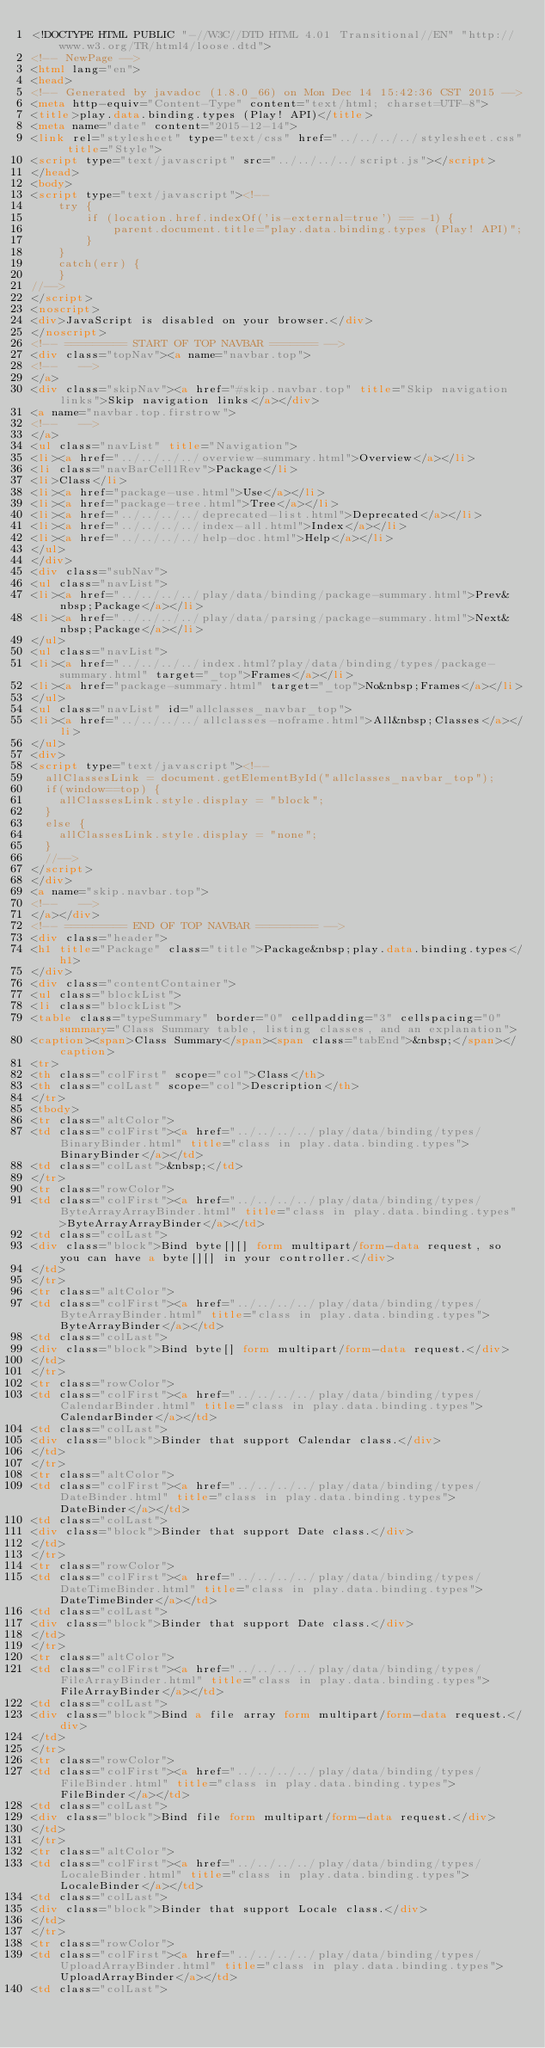Convert code to text. <code><loc_0><loc_0><loc_500><loc_500><_HTML_><!DOCTYPE HTML PUBLIC "-//W3C//DTD HTML 4.01 Transitional//EN" "http://www.w3.org/TR/html4/loose.dtd">
<!-- NewPage -->
<html lang="en">
<head>
<!-- Generated by javadoc (1.8.0_66) on Mon Dec 14 15:42:36 CST 2015 -->
<meta http-equiv="Content-Type" content="text/html; charset=UTF-8">
<title>play.data.binding.types (Play! API)</title>
<meta name="date" content="2015-12-14">
<link rel="stylesheet" type="text/css" href="../../../../stylesheet.css" title="Style">
<script type="text/javascript" src="../../../../script.js"></script>
</head>
<body>
<script type="text/javascript"><!--
    try {
        if (location.href.indexOf('is-external=true') == -1) {
            parent.document.title="play.data.binding.types (Play! API)";
        }
    }
    catch(err) {
    }
//-->
</script>
<noscript>
<div>JavaScript is disabled on your browser.</div>
</noscript>
<!-- ========= START OF TOP NAVBAR ======= -->
<div class="topNav"><a name="navbar.top">
<!--   -->
</a>
<div class="skipNav"><a href="#skip.navbar.top" title="Skip navigation links">Skip navigation links</a></div>
<a name="navbar.top.firstrow">
<!--   -->
</a>
<ul class="navList" title="Navigation">
<li><a href="../../../../overview-summary.html">Overview</a></li>
<li class="navBarCell1Rev">Package</li>
<li>Class</li>
<li><a href="package-use.html">Use</a></li>
<li><a href="package-tree.html">Tree</a></li>
<li><a href="../../../../deprecated-list.html">Deprecated</a></li>
<li><a href="../../../../index-all.html">Index</a></li>
<li><a href="../../../../help-doc.html">Help</a></li>
</ul>
</div>
<div class="subNav">
<ul class="navList">
<li><a href="../../../../play/data/binding/package-summary.html">Prev&nbsp;Package</a></li>
<li><a href="../../../../play/data/parsing/package-summary.html">Next&nbsp;Package</a></li>
</ul>
<ul class="navList">
<li><a href="../../../../index.html?play/data/binding/types/package-summary.html" target="_top">Frames</a></li>
<li><a href="package-summary.html" target="_top">No&nbsp;Frames</a></li>
</ul>
<ul class="navList" id="allclasses_navbar_top">
<li><a href="../../../../allclasses-noframe.html">All&nbsp;Classes</a></li>
</ul>
<div>
<script type="text/javascript"><!--
  allClassesLink = document.getElementById("allclasses_navbar_top");
  if(window==top) {
    allClassesLink.style.display = "block";
  }
  else {
    allClassesLink.style.display = "none";
  }
  //-->
</script>
</div>
<a name="skip.navbar.top">
<!--   -->
</a></div>
<!-- ========= END OF TOP NAVBAR ========= -->
<div class="header">
<h1 title="Package" class="title">Package&nbsp;play.data.binding.types</h1>
</div>
<div class="contentContainer">
<ul class="blockList">
<li class="blockList">
<table class="typeSummary" border="0" cellpadding="3" cellspacing="0" summary="Class Summary table, listing classes, and an explanation">
<caption><span>Class Summary</span><span class="tabEnd">&nbsp;</span></caption>
<tr>
<th class="colFirst" scope="col">Class</th>
<th class="colLast" scope="col">Description</th>
</tr>
<tbody>
<tr class="altColor">
<td class="colFirst"><a href="../../../../play/data/binding/types/BinaryBinder.html" title="class in play.data.binding.types">BinaryBinder</a></td>
<td class="colLast">&nbsp;</td>
</tr>
<tr class="rowColor">
<td class="colFirst"><a href="../../../../play/data/binding/types/ByteArrayArrayBinder.html" title="class in play.data.binding.types">ByteArrayArrayBinder</a></td>
<td class="colLast">
<div class="block">Bind byte[][] form multipart/form-data request, so you can have a byte[][] in your controller.</div>
</td>
</tr>
<tr class="altColor">
<td class="colFirst"><a href="../../../../play/data/binding/types/ByteArrayBinder.html" title="class in play.data.binding.types">ByteArrayBinder</a></td>
<td class="colLast">
<div class="block">Bind byte[] form multipart/form-data request.</div>
</td>
</tr>
<tr class="rowColor">
<td class="colFirst"><a href="../../../../play/data/binding/types/CalendarBinder.html" title="class in play.data.binding.types">CalendarBinder</a></td>
<td class="colLast">
<div class="block">Binder that support Calendar class.</div>
</td>
</tr>
<tr class="altColor">
<td class="colFirst"><a href="../../../../play/data/binding/types/DateBinder.html" title="class in play.data.binding.types">DateBinder</a></td>
<td class="colLast">
<div class="block">Binder that support Date class.</div>
</td>
</tr>
<tr class="rowColor">
<td class="colFirst"><a href="../../../../play/data/binding/types/DateTimeBinder.html" title="class in play.data.binding.types">DateTimeBinder</a></td>
<td class="colLast">
<div class="block">Binder that support Date class.</div>
</td>
</tr>
<tr class="altColor">
<td class="colFirst"><a href="../../../../play/data/binding/types/FileArrayBinder.html" title="class in play.data.binding.types">FileArrayBinder</a></td>
<td class="colLast">
<div class="block">Bind a file array form multipart/form-data request.</div>
</td>
</tr>
<tr class="rowColor">
<td class="colFirst"><a href="../../../../play/data/binding/types/FileBinder.html" title="class in play.data.binding.types">FileBinder</a></td>
<td class="colLast">
<div class="block">Bind file form multipart/form-data request.</div>
</td>
</tr>
<tr class="altColor">
<td class="colFirst"><a href="../../../../play/data/binding/types/LocaleBinder.html" title="class in play.data.binding.types">LocaleBinder</a></td>
<td class="colLast">
<div class="block">Binder that support Locale class.</div>
</td>
</tr>
<tr class="rowColor">
<td class="colFirst"><a href="../../../../play/data/binding/types/UploadArrayBinder.html" title="class in play.data.binding.types">UploadArrayBinder</a></td>
<td class="colLast"></code> 